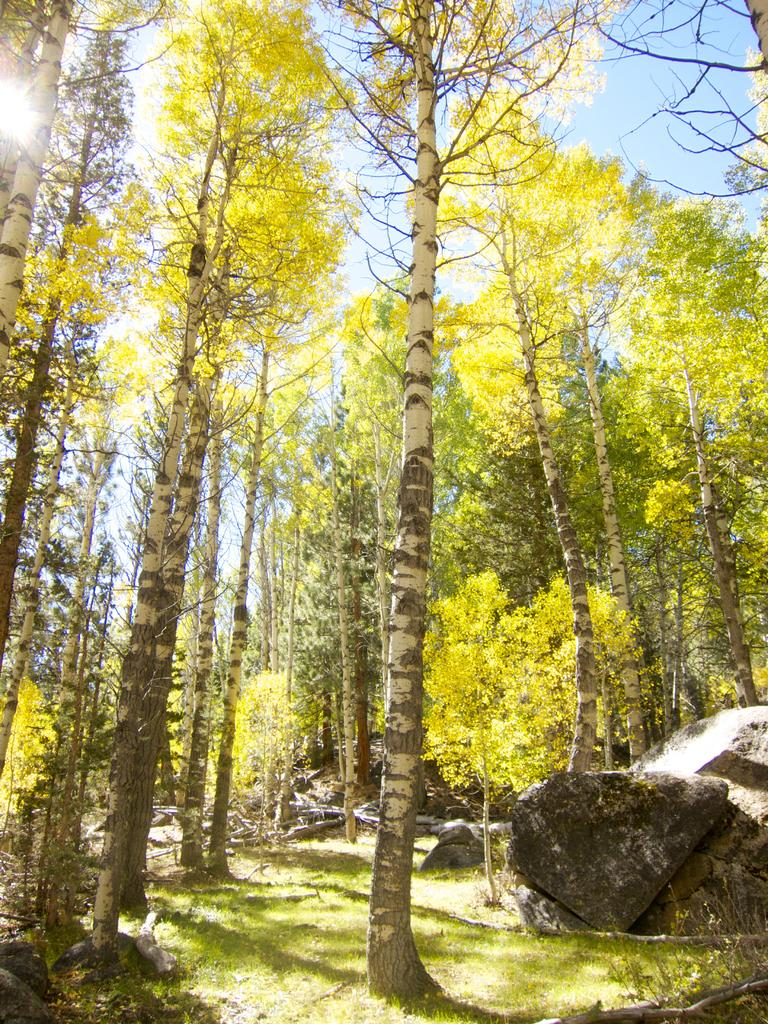What type of vegetation can be seen in the image? There are trees in the image. What other natural elements are present in the image? There are rocks and grass in the image. Are there any man-made objects in the image? Yes, there are other objects in the image. What can be seen in the background of the image? The sky, the sun, and possibly more natural elements are visible in the background of the image. How many sticks are being used to wash the trees in the image? There are no sticks or washing activity depicted in the image; it features trees, rocks, grass, and other objects. 